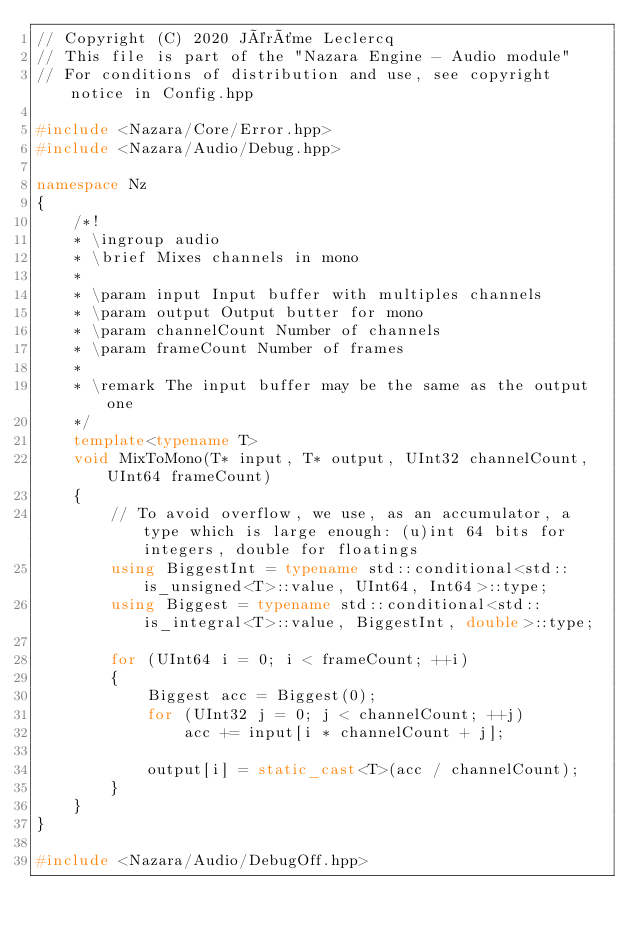Convert code to text. <code><loc_0><loc_0><loc_500><loc_500><_C++_>// Copyright (C) 2020 Jérôme Leclercq
// This file is part of the "Nazara Engine - Audio module"
// For conditions of distribution and use, see copyright notice in Config.hpp

#include <Nazara/Core/Error.hpp>
#include <Nazara/Audio/Debug.hpp>

namespace Nz
{
	/*!
	* \ingroup audio
	* \brief Mixes channels in mono
	*
	* \param input Input buffer with multiples channels
	* \param output Output butter for mono
	* \param channelCount Number of channels
	* \param frameCount Number of frames
	*
	* \remark The input buffer may be the same as the output one
	*/
	template<typename T>
	void MixToMono(T* input, T* output, UInt32 channelCount, UInt64 frameCount)
	{
		// To avoid overflow, we use, as an accumulator, a type which is large enough: (u)int 64 bits for integers, double for floatings
		using BiggestInt = typename std::conditional<std::is_unsigned<T>::value, UInt64, Int64>::type;
		using Biggest = typename std::conditional<std::is_integral<T>::value, BiggestInt, double>::type;

		for (UInt64 i = 0; i < frameCount; ++i)
		{
			Biggest acc = Biggest(0);
			for (UInt32 j = 0; j < channelCount; ++j)
				acc += input[i * channelCount + j];

			output[i] = static_cast<T>(acc / channelCount);
		}
	}
}

#include <Nazara/Audio/DebugOff.hpp>
</code> 